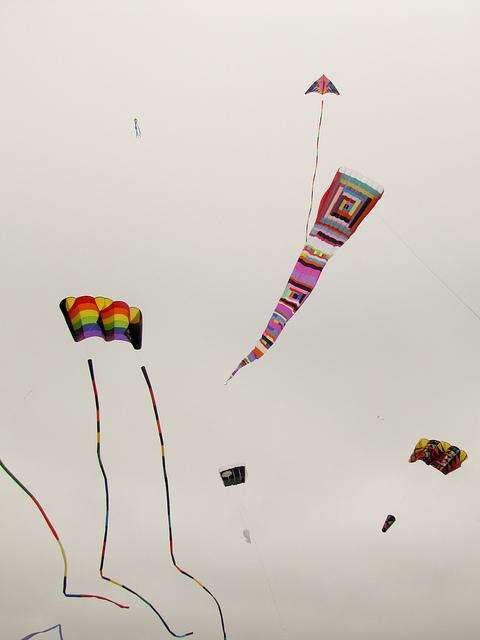What is rising in the air? Please explain your reasoning. kite. These are cloth being held by strings 